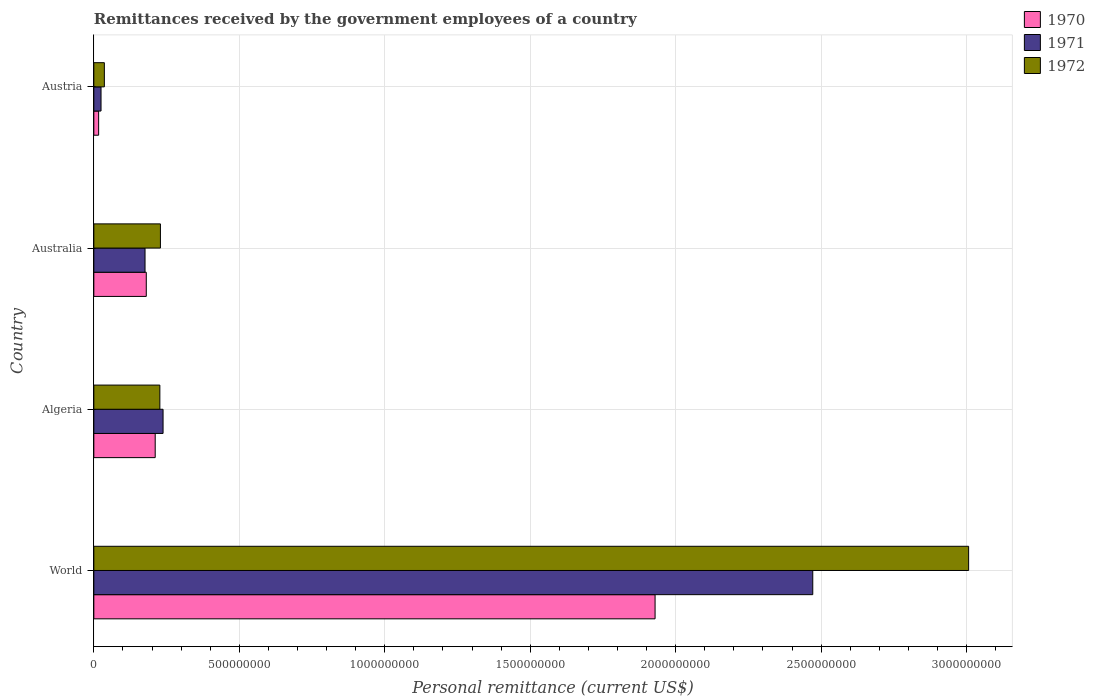How many groups of bars are there?
Provide a short and direct response. 4. How many bars are there on the 1st tick from the top?
Provide a succinct answer. 3. What is the label of the 1st group of bars from the top?
Ensure brevity in your answer.  Austria. In how many cases, is the number of bars for a given country not equal to the number of legend labels?
Provide a succinct answer. 0. What is the remittances received by the government employees in 1970 in Algeria?
Provide a short and direct response. 2.11e+08. Across all countries, what is the maximum remittances received by the government employees in 1972?
Make the answer very short. 3.01e+09. Across all countries, what is the minimum remittances received by the government employees in 1971?
Offer a very short reply. 2.48e+07. In which country was the remittances received by the government employees in 1971 maximum?
Keep it short and to the point. World. What is the total remittances received by the government employees in 1972 in the graph?
Offer a very short reply. 3.50e+09. What is the difference between the remittances received by the government employees in 1970 in Australia and that in World?
Your answer should be compact. -1.75e+09. What is the difference between the remittances received by the government employees in 1972 in World and the remittances received by the government employees in 1970 in Austria?
Provide a succinct answer. 2.99e+09. What is the average remittances received by the government employees in 1971 per country?
Give a very brief answer. 7.28e+08. What is the difference between the remittances received by the government employees in 1970 and remittances received by the government employees in 1972 in World?
Keep it short and to the point. -1.08e+09. In how many countries, is the remittances received by the government employees in 1972 greater than 900000000 US$?
Keep it short and to the point. 1. What is the ratio of the remittances received by the government employees in 1970 in Algeria to that in World?
Make the answer very short. 0.11. Is the difference between the remittances received by the government employees in 1970 in Algeria and Australia greater than the difference between the remittances received by the government employees in 1972 in Algeria and Australia?
Give a very brief answer. Yes. What is the difference between the highest and the second highest remittances received by the government employees in 1971?
Offer a very short reply. 2.23e+09. What is the difference between the highest and the lowest remittances received by the government employees in 1972?
Your answer should be compact. 2.97e+09. Does the graph contain any zero values?
Keep it short and to the point. No. Does the graph contain grids?
Your answer should be compact. Yes. How many legend labels are there?
Give a very brief answer. 3. What is the title of the graph?
Offer a very short reply. Remittances received by the government employees of a country. Does "1962" appear as one of the legend labels in the graph?
Provide a succinct answer. No. What is the label or title of the X-axis?
Keep it short and to the point. Personal remittance (current US$). What is the Personal remittance (current US$) of 1970 in World?
Provide a short and direct response. 1.93e+09. What is the Personal remittance (current US$) in 1971 in World?
Give a very brief answer. 2.47e+09. What is the Personal remittance (current US$) in 1972 in World?
Offer a very short reply. 3.01e+09. What is the Personal remittance (current US$) in 1970 in Algeria?
Provide a short and direct response. 2.11e+08. What is the Personal remittance (current US$) of 1971 in Algeria?
Ensure brevity in your answer.  2.38e+08. What is the Personal remittance (current US$) in 1972 in Algeria?
Keep it short and to the point. 2.27e+08. What is the Personal remittance (current US$) in 1970 in Australia?
Your response must be concise. 1.80e+08. What is the Personal remittance (current US$) in 1971 in Australia?
Make the answer very short. 1.76e+08. What is the Personal remittance (current US$) of 1972 in Australia?
Your answer should be compact. 2.29e+08. What is the Personal remittance (current US$) of 1970 in Austria?
Keep it short and to the point. 1.66e+07. What is the Personal remittance (current US$) in 1971 in Austria?
Provide a short and direct response. 2.48e+07. What is the Personal remittance (current US$) of 1972 in Austria?
Offer a terse response. 3.62e+07. Across all countries, what is the maximum Personal remittance (current US$) in 1970?
Provide a succinct answer. 1.93e+09. Across all countries, what is the maximum Personal remittance (current US$) in 1971?
Offer a very short reply. 2.47e+09. Across all countries, what is the maximum Personal remittance (current US$) of 1972?
Your response must be concise. 3.01e+09. Across all countries, what is the minimum Personal remittance (current US$) of 1970?
Your answer should be compact. 1.66e+07. Across all countries, what is the minimum Personal remittance (current US$) in 1971?
Make the answer very short. 2.48e+07. Across all countries, what is the minimum Personal remittance (current US$) in 1972?
Ensure brevity in your answer.  3.62e+07. What is the total Personal remittance (current US$) in 1970 in the graph?
Keep it short and to the point. 2.34e+09. What is the total Personal remittance (current US$) in 1971 in the graph?
Offer a terse response. 2.91e+09. What is the total Personal remittance (current US$) in 1972 in the graph?
Your answer should be very brief. 3.50e+09. What is the difference between the Personal remittance (current US$) in 1970 in World and that in Algeria?
Provide a succinct answer. 1.72e+09. What is the difference between the Personal remittance (current US$) in 1971 in World and that in Algeria?
Offer a terse response. 2.23e+09. What is the difference between the Personal remittance (current US$) of 1972 in World and that in Algeria?
Keep it short and to the point. 2.78e+09. What is the difference between the Personal remittance (current US$) of 1970 in World and that in Australia?
Your answer should be very brief. 1.75e+09. What is the difference between the Personal remittance (current US$) of 1971 in World and that in Australia?
Ensure brevity in your answer.  2.30e+09. What is the difference between the Personal remittance (current US$) in 1972 in World and that in Australia?
Make the answer very short. 2.78e+09. What is the difference between the Personal remittance (current US$) in 1970 in World and that in Austria?
Offer a terse response. 1.91e+09. What is the difference between the Personal remittance (current US$) of 1971 in World and that in Austria?
Your answer should be compact. 2.45e+09. What is the difference between the Personal remittance (current US$) of 1972 in World and that in Austria?
Your response must be concise. 2.97e+09. What is the difference between the Personal remittance (current US$) in 1970 in Algeria and that in Australia?
Your answer should be compact. 3.07e+07. What is the difference between the Personal remittance (current US$) of 1971 in Algeria and that in Australia?
Your answer should be very brief. 6.20e+07. What is the difference between the Personal remittance (current US$) of 1972 in Algeria and that in Australia?
Offer a terse response. -1.96e+06. What is the difference between the Personal remittance (current US$) in 1970 in Algeria and that in Austria?
Make the answer very short. 1.94e+08. What is the difference between the Personal remittance (current US$) of 1971 in Algeria and that in Austria?
Make the answer very short. 2.13e+08. What is the difference between the Personal remittance (current US$) in 1972 in Algeria and that in Austria?
Make the answer very short. 1.91e+08. What is the difference between the Personal remittance (current US$) of 1970 in Australia and that in Austria?
Keep it short and to the point. 1.64e+08. What is the difference between the Personal remittance (current US$) in 1971 in Australia and that in Austria?
Your response must be concise. 1.51e+08. What is the difference between the Personal remittance (current US$) in 1972 in Australia and that in Austria?
Your response must be concise. 1.93e+08. What is the difference between the Personal remittance (current US$) of 1970 in World and the Personal remittance (current US$) of 1971 in Algeria?
Make the answer very short. 1.69e+09. What is the difference between the Personal remittance (current US$) of 1970 in World and the Personal remittance (current US$) of 1972 in Algeria?
Provide a succinct answer. 1.70e+09. What is the difference between the Personal remittance (current US$) in 1971 in World and the Personal remittance (current US$) in 1972 in Algeria?
Keep it short and to the point. 2.24e+09. What is the difference between the Personal remittance (current US$) of 1970 in World and the Personal remittance (current US$) of 1971 in Australia?
Ensure brevity in your answer.  1.75e+09. What is the difference between the Personal remittance (current US$) of 1970 in World and the Personal remittance (current US$) of 1972 in Australia?
Provide a succinct answer. 1.70e+09. What is the difference between the Personal remittance (current US$) of 1971 in World and the Personal remittance (current US$) of 1972 in Australia?
Keep it short and to the point. 2.24e+09. What is the difference between the Personal remittance (current US$) in 1970 in World and the Personal remittance (current US$) in 1971 in Austria?
Ensure brevity in your answer.  1.90e+09. What is the difference between the Personal remittance (current US$) of 1970 in World and the Personal remittance (current US$) of 1972 in Austria?
Keep it short and to the point. 1.89e+09. What is the difference between the Personal remittance (current US$) in 1971 in World and the Personal remittance (current US$) in 1972 in Austria?
Give a very brief answer. 2.44e+09. What is the difference between the Personal remittance (current US$) in 1970 in Algeria and the Personal remittance (current US$) in 1971 in Australia?
Ensure brevity in your answer.  3.50e+07. What is the difference between the Personal remittance (current US$) of 1970 in Algeria and the Personal remittance (current US$) of 1972 in Australia?
Provide a short and direct response. -1.80e+07. What is the difference between the Personal remittance (current US$) in 1971 in Algeria and the Personal remittance (current US$) in 1972 in Australia?
Keep it short and to the point. 9.04e+06. What is the difference between the Personal remittance (current US$) in 1970 in Algeria and the Personal remittance (current US$) in 1971 in Austria?
Ensure brevity in your answer.  1.86e+08. What is the difference between the Personal remittance (current US$) of 1970 in Algeria and the Personal remittance (current US$) of 1972 in Austria?
Make the answer very short. 1.75e+08. What is the difference between the Personal remittance (current US$) of 1971 in Algeria and the Personal remittance (current US$) of 1972 in Austria?
Make the answer very short. 2.02e+08. What is the difference between the Personal remittance (current US$) of 1970 in Australia and the Personal remittance (current US$) of 1971 in Austria?
Your answer should be very brief. 1.56e+08. What is the difference between the Personal remittance (current US$) of 1970 in Australia and the Personal remittance (current US$) of 1972 in Austria?
Give a very brief answer. 1.44e+08. What is the difference between the Personal remittance (current US$) of 1971 in Australia and the Personal remittance (current US$) of 1972 in Austria?
Ensure brevity in your answer.  1.40e+08. What is the average Personal remittance (current US$) in 1970 per country?
Ensure brevity in your answer.  5.84e+08. What is the average Personal remittance (current US$) of 1971 per country?
Offer a terse response. 7.28e+08. What is the average Personal remittance (current US$) of 1972 per country?
Provide a succinct answer. 8.75e+08. What is the difference between the Personal remittance (current US$) of 1970 and Personal remittance (current US$) of 1971 in World?
Your response must be concise. -5.42e+08. What is the difference between the Personal remittance (current US$) in 1970 and Personal remittance (current US$) in 1972 in World?
Provide a short and direct response. -1.08e+09. What is the difference between the Personal remittance (current US$) of 1971 and Personal remittance (current US$) of 1972 in World?
Offer a terse response. -5.36e+08. What is the difference between the Personal remittance (current US$) in 1970 and Personal remittance (current US$) in 1971 in Algeria?
Provide a short and direct response. -2.70e+07. What is the difference between the Personal remittance (current US$) in 1970 and Personal remittance (current US$) in 1972 in Algeria?
Provide a short and direct response. -1.60e+07. What is the difference between the Personal remittance (current US$) in 1971 and Personal remittance (current US$) in 1972 in Algeria?
Keep it short and to the point. 1.10e+07. What is the difference between the Personal remittance (current US$) in 1970 and Personal remittance (current US$) in 1971 in Australia?
Keep it short and to the point. 4.27e+06. What is the difference between the Personal remittance (current US$) in 1970 and Personal remittance (current US$) in 1972 in Australia?
Keep it short and to the point. -4.86e+07. What is the difference between the Personal remittance (current US$) in 1971 and Personal remittance (current US$) in 1972 in Australia?
Your answer should be compact. -5.29e+07. What is the difference between the Personal remittance (current US$) of 1970 and Personal remittance (current US$) of 1971 in Austria?
Offer a very short reply. -8.18e+06. What is the difference between the Personal remittance (current US$) of 1970 and Personal remittance (current US$) of 1972 in Austria?
Keep it short and to the point. -1.97e+07. What is the difference between the Personal remittance (current US$) of 1971 and Personal remittance (current US$) of 1972 in Austria?
Provide a succinct answer. -1.15e+07. What is the ratio of the Personal remittance (current US$) in 1970 in World to that in Algeria?
Give a very brief answer. 9.14. What is the ratio of the Personal remittance (current US$) in 1971 in World to that in Algeria?
Offer a very short reply. 10.38. What is the ratio of the Personal remittance (current US$) of 1972 in World to that in Algeria?
Offer a terse response. 13.25. What is the ratio of the Personal remittance (current US$) in 1970 in World to that in Australia?
Offer a terse response. 10.7. What is the ratio of the Personal remittance (current US$) in 1971 in World to that in Australia?
Provide a short and direct response. 14.04. What is the ratio of the Personal remittance (current US$) in 1972 in World to that in Australia?
Keep it short and to the point. 13.13. What is the ratio of the Personal remittance (current US$) of 1970 in World to that in Austria?
Your answer should be compact. 116.38. What is the ratio of the Personal remittance (current US$) of 1971 in World to that in Austria?
Offer a very short reply. 99.81. What is the ratio of the Personal remittance (current US$) in 1972 in World to that in Austria?
Your answer should be compact. 82.96. What is the ratio of the Personal remittance (current US$) in 1970 in Algeria to that in Australia?
Your response must be concise. 1.17. What is the ratio of the Personal remittance (current US$) in 1971 in Algeria to that in Australia?
Make the answer very short. 1.35. What is the ratio of the Personal remittance (current US$) in 1970 in Algeria to that in Austria?
Make the answer very short. 12.73. What is the ratio of the Personal remittance (current US$) in 1971 in Algeria to that in Austria?
Keep it short and to the point. 9.61. What is the ratio of the Personal remittance (current US$) in 1972 in Algeria to that in Austria?
Keep it short and to the point. 6.26. What is the ratio of the Personal remittance (current US$) of 1970 in Australia to that in Austria?
Keep it short and to the point. 10.88. What is the ratio of the Personal remittance (current US$) of 1971 in Australia to that in Austria?
Keep it short and to the point. 7.11. What is the ratio of the Personal remittance (current US$) of 1972 in Australia to that in Austria?
Provide a succinct answer. 6.32. What is the difference between the highest and the second highest Personal remittance (current US$) of 1970?
Your answer should be very brief. 1.72e+09. What is the difference between the highest and the second highest Personal remittance (current US$) in 1971?
Offer a terse response. 2.23e+09. What is the difference between the highest and the second highest Personal remittance (current US$) of 1972?
Ensure brevity in your answer.  2.78e+09. What is the difference between the highest and the lowest Personal remittance (current US$) in 1970?
Your response must be concise. 1.91e+09. What is the difference between the highest and the lowest Personal remittance (current US$) in 1971?
Provide a short and direct response. 2.45e+09. What is the difference between the highest and the lowest Personal remittance (current US$) of 1972?
Make the answer very short. 2.97e+09. 